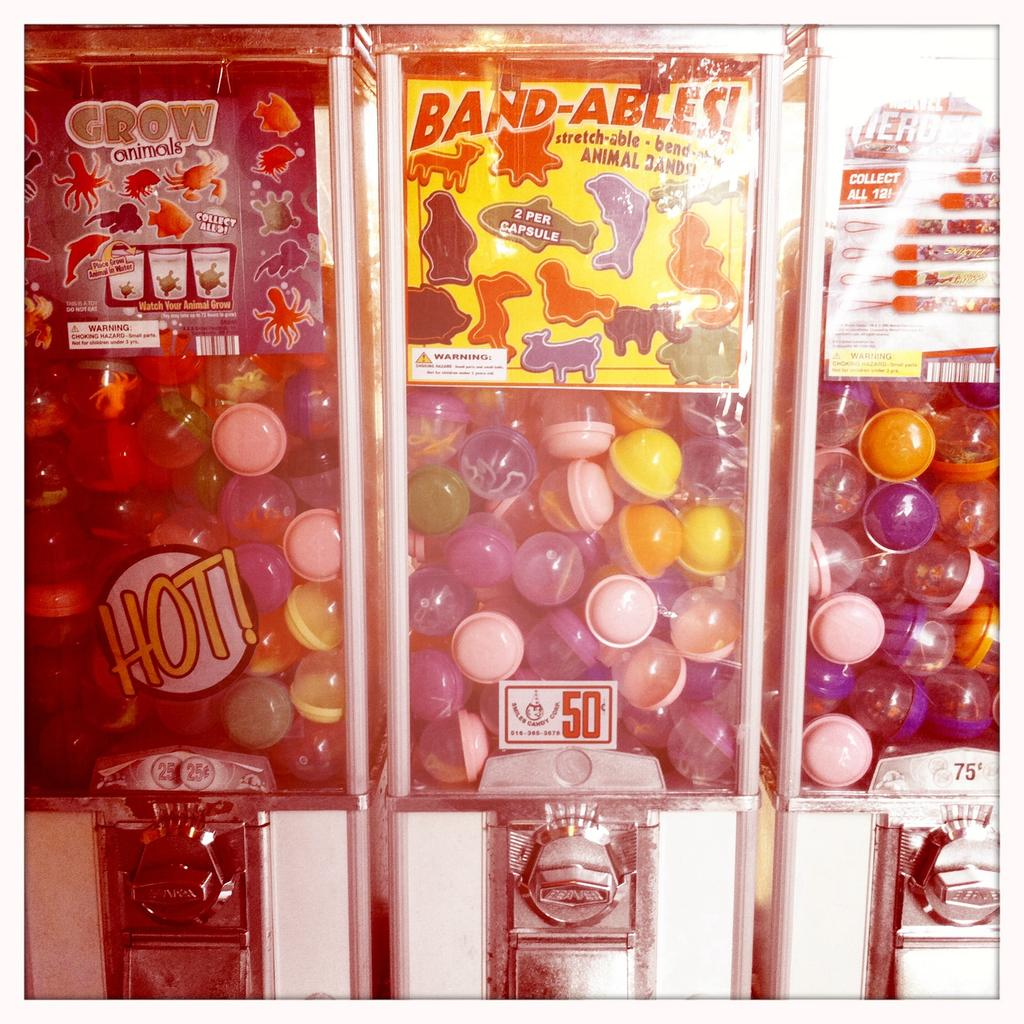What is the main object in the image? There is a machine in the image. What can be seen on the machine? There are boxes on the machine and posters pasted on it. How many birds are sitting on the head of the machine in the image? There are no birds present in the image, and the machine does not have a head. 